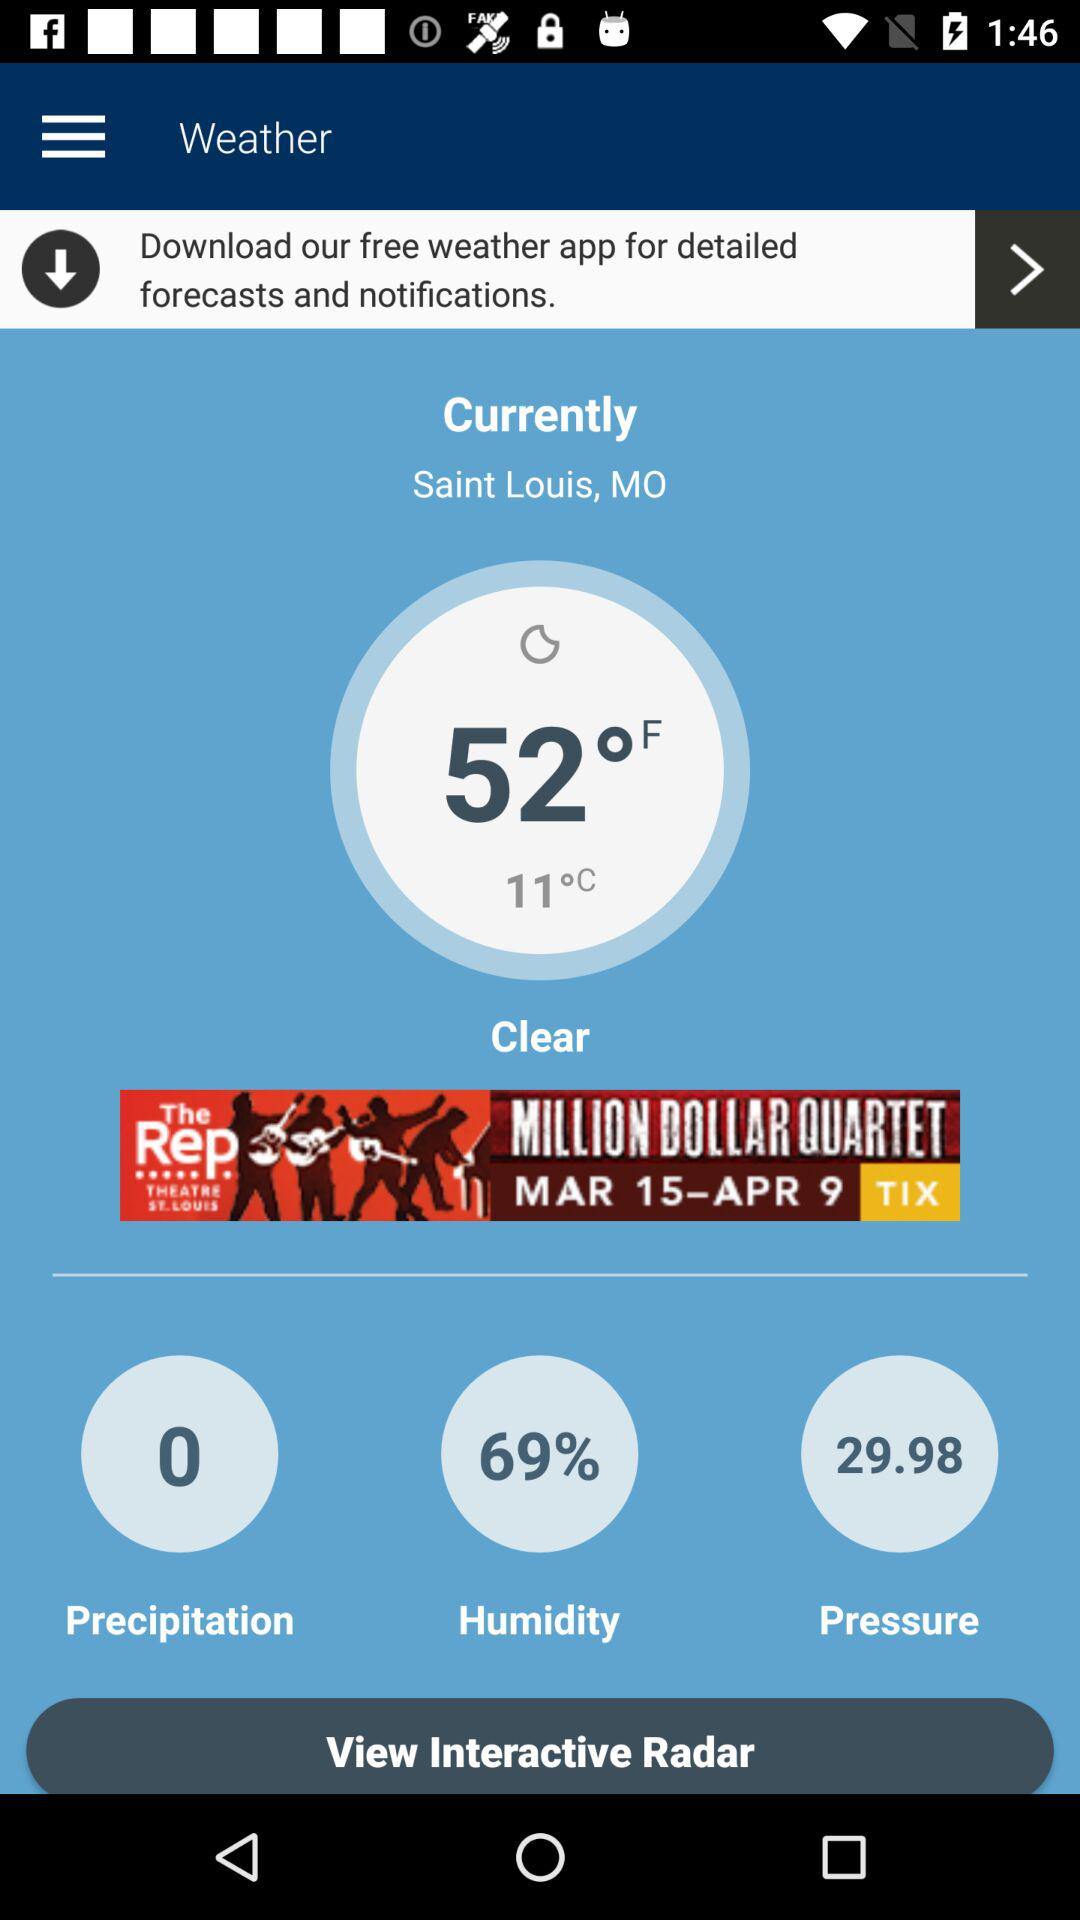What's the "Precipitation"?
Answer the question using a single word or phrase. "Precipitation" is 0. 